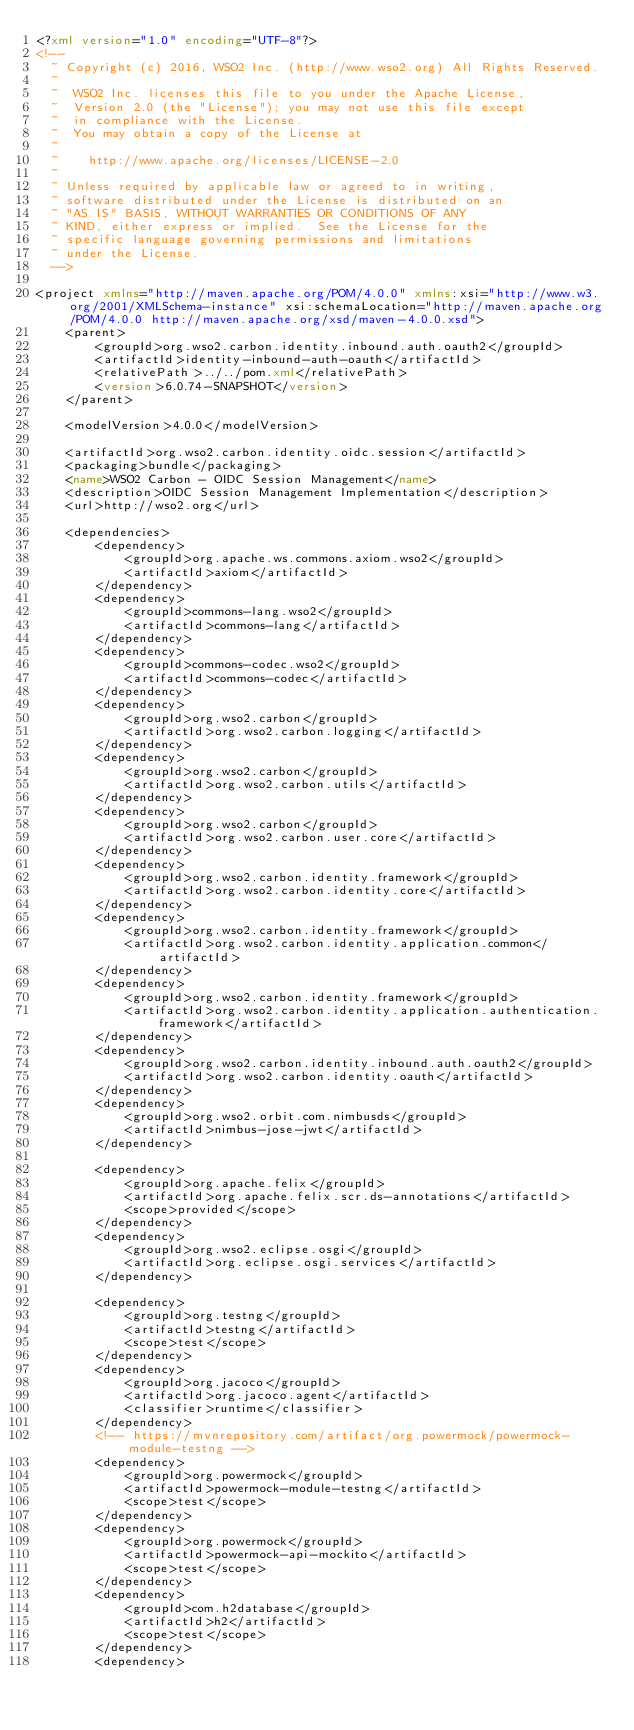<code> <loc_0><loc_0><loc_500><loc_500><_XML_><?xml version="1.0" encoding="UTF-8"?>
<!--
  ~ Copyright (c) 2016, WSO2 Inc. (http://www.wso2.org) All Rights Reserved.
  ~
  ~  WSO2 Inc. licenses this file to you under the Apache License,
  ~  Version 2.0 (the "License"); you may not use this file except
  ~  in compliance with the License.
  ~  You may obtain a copy of the License at
  ~
  ~    http://www.apache.org/licenses/LICENSE-2.0
  ~
  ~ Unless required by applicable law or agreed to in writing,
  ~ software distributed under the License is distributed on an
  ~ "AS IS" BASIS, WITHOUT WARRANTIES OR CONDITIONS OF ANY
  ~ KIND, either express or implied.  See the License for the
  ~ specific language governing permissions and limitations
  ~ under the License.
  -->

<project xmlns="http://maven.apache.org/POM/4.0.0" xmlns:xsi="http://www.w3.org/2001/XMLSchema-instance" xsi:schemaLocation="http://maven.apache.org/POM/4.0.0 http://maven.apache.org/xsd/maven-4.0.0.xsd">
    <parent>
        <groupId>org.wso2.carbon.identity.inbound.auth.oauth2</groupId>
        <artifactId>identity-inbound-auth-oauth</artifactId>
        <relativePath>../../pom.xml</relativePath>
        <version>6.0.74-SNAPSHOT</version>
    </parent>

    <modelVersion>4.0.0</modelVersion>

    <artifactId>org.wso2.carbon.identity.oidc.session</artifactId>
    <packaging>bundle</packaging>
    <name>WSO2 Carbon - OIDC Session Management</name>
    <description>OIDC Session Management Implementation</description>
    <url>http://wso2.org</url>

    <dependencies>
        <dependency>
            <groupId>org.apache.ws.commons.axiom.wso2</groupId>
            <artifactId>axiom</artifactId>
        </dependency>
        <dependency>
            <groupId>commons-lang.wso2</groupId>
            <artifactId>commons-lang</artifactId>
        </dependency>
        <dependency>
            <groupId>commons-codec.wso2</groupId>
            <artifactId>commons-codec</artifactId>
        </dependency>
        <dependency>
            <groupId>org.wso2.carbon</groupId>
            <artifactId>org.wso2.carbon.logging</artifactId>
        </dependency>
        <dependency>
            <groupId>org.wso2.carbon</groupId>
            <artifactId>org.wso2.carbon.utils</artifactId>
        </dependency>
        <dependency>
            <groupId>org.wso2.carbon</groupId>
            <artifactId>org.wso2.carbon.user.core</artifactId>
        </dependency>
        <dependency>
            <groupId>org.wso2.carbon.identity.framework</groupId>
            <artifactId>org.wso2.carbon.identity.core</artifactId>
        </dependency>
        <dependency>
            <groupId>org.wso2.carbon.identity.framework</groupId>
            <artifactId>org.wso2.carbon.identity.application.common</artifactId>
        </dependency>
        <dependency>
            <groupId>org.wso2.carbon.identity.framework</groupId>
            <artifactId>org.wso2.carbon.identity.application.authentication.framework</artifactId>
        </dependency>
        <dependency>
            <groupId>org.wso2.carbon.identity.inbound.auth.oauth2</groupId>
            <artifactId>org.wso2.carbon.identity.oauth</artifactId>
        </dependency>
        <dependency>
            <groupId>org.wso2.orbit.com.nimbusds</groupId>
            <artifactId>nimbus-jose-jwt</artifactId>
        </dependency>

        <dependency>
            <groupId>org.apache.felix</groupId>
            <artifactId>org.apache.felix.scr.ds-annotations</artifactId>
            <scope>provided</scope>
        </dependency>
        <dependency>
            <groupId>org.wso2.eclipse.osgi</groupId>
            <artifactId>org.eclipse.osgi.services</artifactId>
        </dependency>

        <dependency>
            <groupId>org.testng</groupId>
            <artifactId>testng</artifactId>
            <scope>test</scope>
        </dependency>
        <dependency>
            <groupId>org.jacoco</groupId>
            <artifactId>org.jacoco.agent</artifactId>
            <classifier>runtime</classifier>
        </dependency>
        <!-- https://mvnrepository.com/artifact/org.powermock/powermock-module-testng -->
        <dependency>
            <groupId>org.powermock</groupId>
            <artifactId>powermock-module-testng</artifactId>
            <scope>test</scope>
        </dependency>
        <dependency>
            <groupId>org.powermock</groupId>
            <artifactId>powermock-api-mockito</artifactId>
            <scope>test</scope>
        </dependency>
        <dependency>
            <groupId>com.h2database</groupId>
            <artifactId>h2</artifactId>
            <scope>test</scope>
        </dependency>
        <dependency></code> 